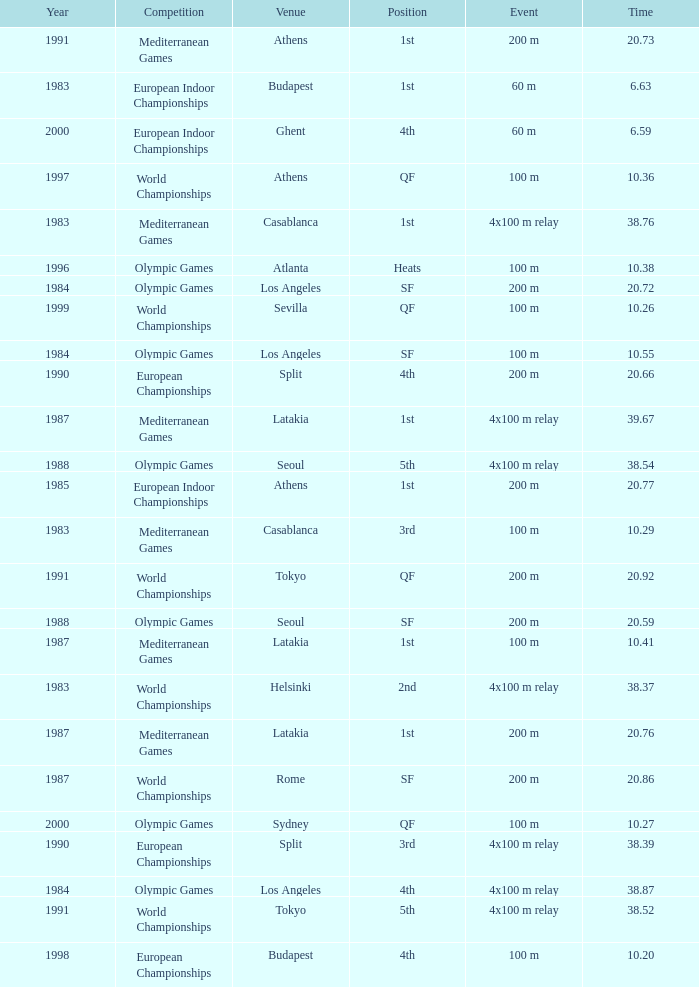What Venue has a Year smaller than 1991, Time larger than 10.29, Competition of mediterranean games, and Event of 4x100 m relay? Casablanca, Latakia. 